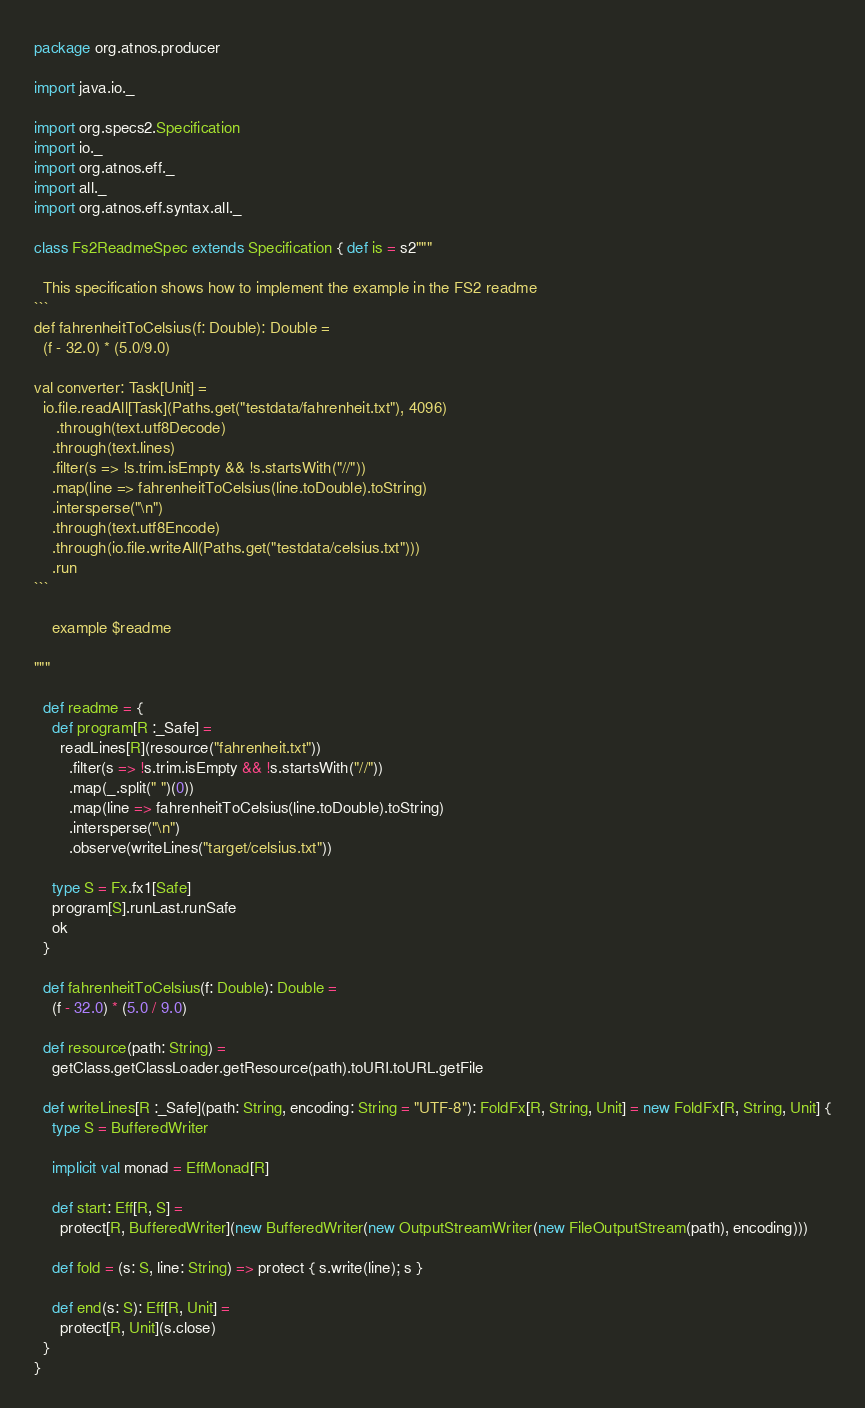<code> <loc_0><loc_0><loc_500><loc_500><_Scala_>package org.atnos.producer

import java.io._

import org.specs2.Specification
import io._
import org.atnos.eff._
import all._
import org.atnos.eff.syntax.all._

class Fs2ReadmeSpec extends Specification { def is = s2"""

  This specification shows how to implement the example in the FS2 readme
```
def fahrenheitToCelsius(f: Double): Double =
  (f - 32.0) * (5.0/9.0)

val converter: Task[Unit] =
  io.file.readAll[Task](Paths.get("testdata/fahrenheit.txt"), 4096)
     .through(text.utf8Decode)
    .through(text.lines)
    .filter(s => !s.trim.isEmpty && !s.startsWith("//"))
    .map(line => fahrenheitToCelsius(line.toDouble).toString)
    .intersperse("\n")
    .through(text.utf8Encode)
    .through(io.file.writeAll(Paths.get("testdata/celsius.txt")))
    .run
```

    example $readme

"""

  def readme = {
    def program[R :_Safe] =
      readLines[R](resource("fahrenheit.txt"))
        .filter(s => !s.trim.isEmpty && !s.startsWith("//"))
        .map(_.split(" ")(0))
        .map(line => fahrenheitToCelsius(line.toDouble).toString)
        .intersperse("\n")
        .observe(writeLines("target/celsius.txt"))

    type S = Fx.fx1[Safe]
    program[S].runLast.runSafe
    ok
  }

  def fahrenheitToCelsius(f: Double): Double =
    (f - 32.0) * (5.0 / 9.0)

  def resource(path: String) =
    getClass.getClassLoader.getResource(path).toURI.toURL.getFile

  def writeLines[R :_Safe](path: String, encoding: String = "UTF-8"): FoldFx[R, String, Unit] = new FoldFx[R, String, Unit] {
    type S = BufferedWriter

    implicit val monad = EffMonad[R]

    def start: Eff[R, S] =
      protect[R, BufferedWriter](new BufferedWriter(new OutputStreamWriter(new FileOutputStream(path), encoding)))

    def fold = (s: S, line: String) => protect { s.write(line); s }

    def end(s: S): Eff[R, Unit] =
      protect[R, Unit](s.close)
  }
}

</code> 